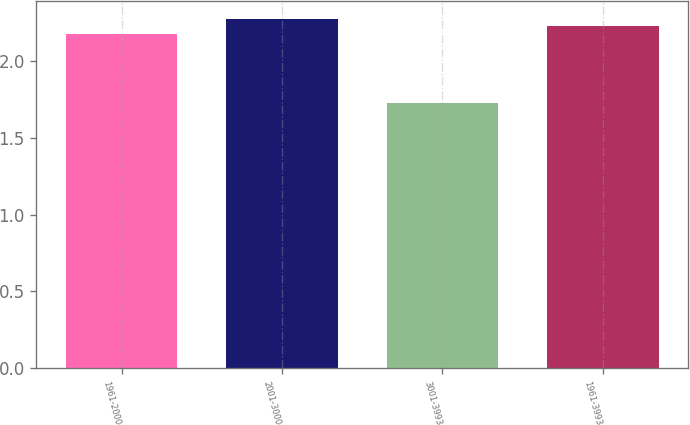<chart> <loc_0><loc_0><loc_500><loc_500><bar_chart><fcel>1961-2000<fcel>2001-3000<fcel>3001-3993<fcel>1961-3993<nl><fcel>2.18<fcel>2.28<fcel>1.73<fcel>2.23<nl></chart> 